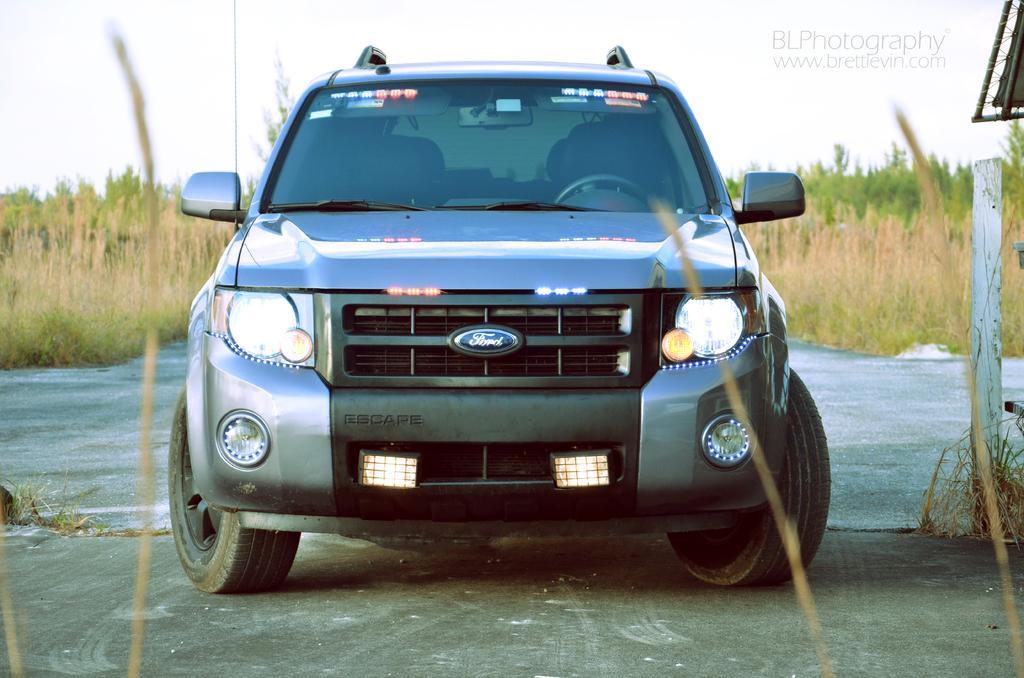Can you describe this image briefly? This picture shows a car and we see plants and trees and a pole on the side. Car is grey in color and we see a cloudy sky. 